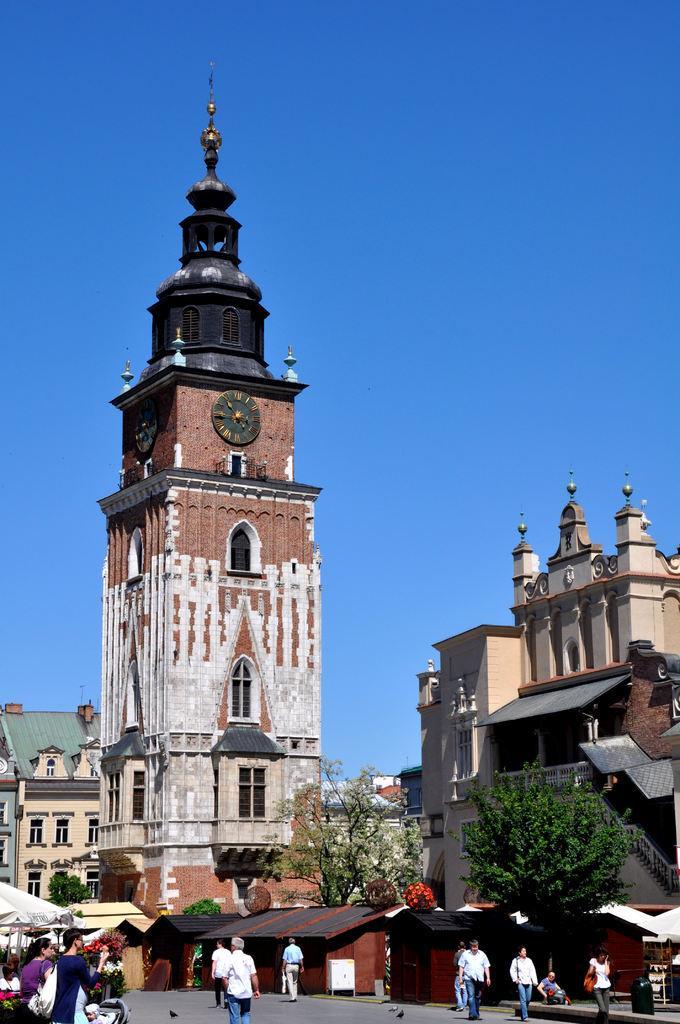Could you give a brief overview of what you see in this image? In this picture I can see there are few people walking in the street and there are trees and buildings. There is a tower here with a clock and the sky is clear. 